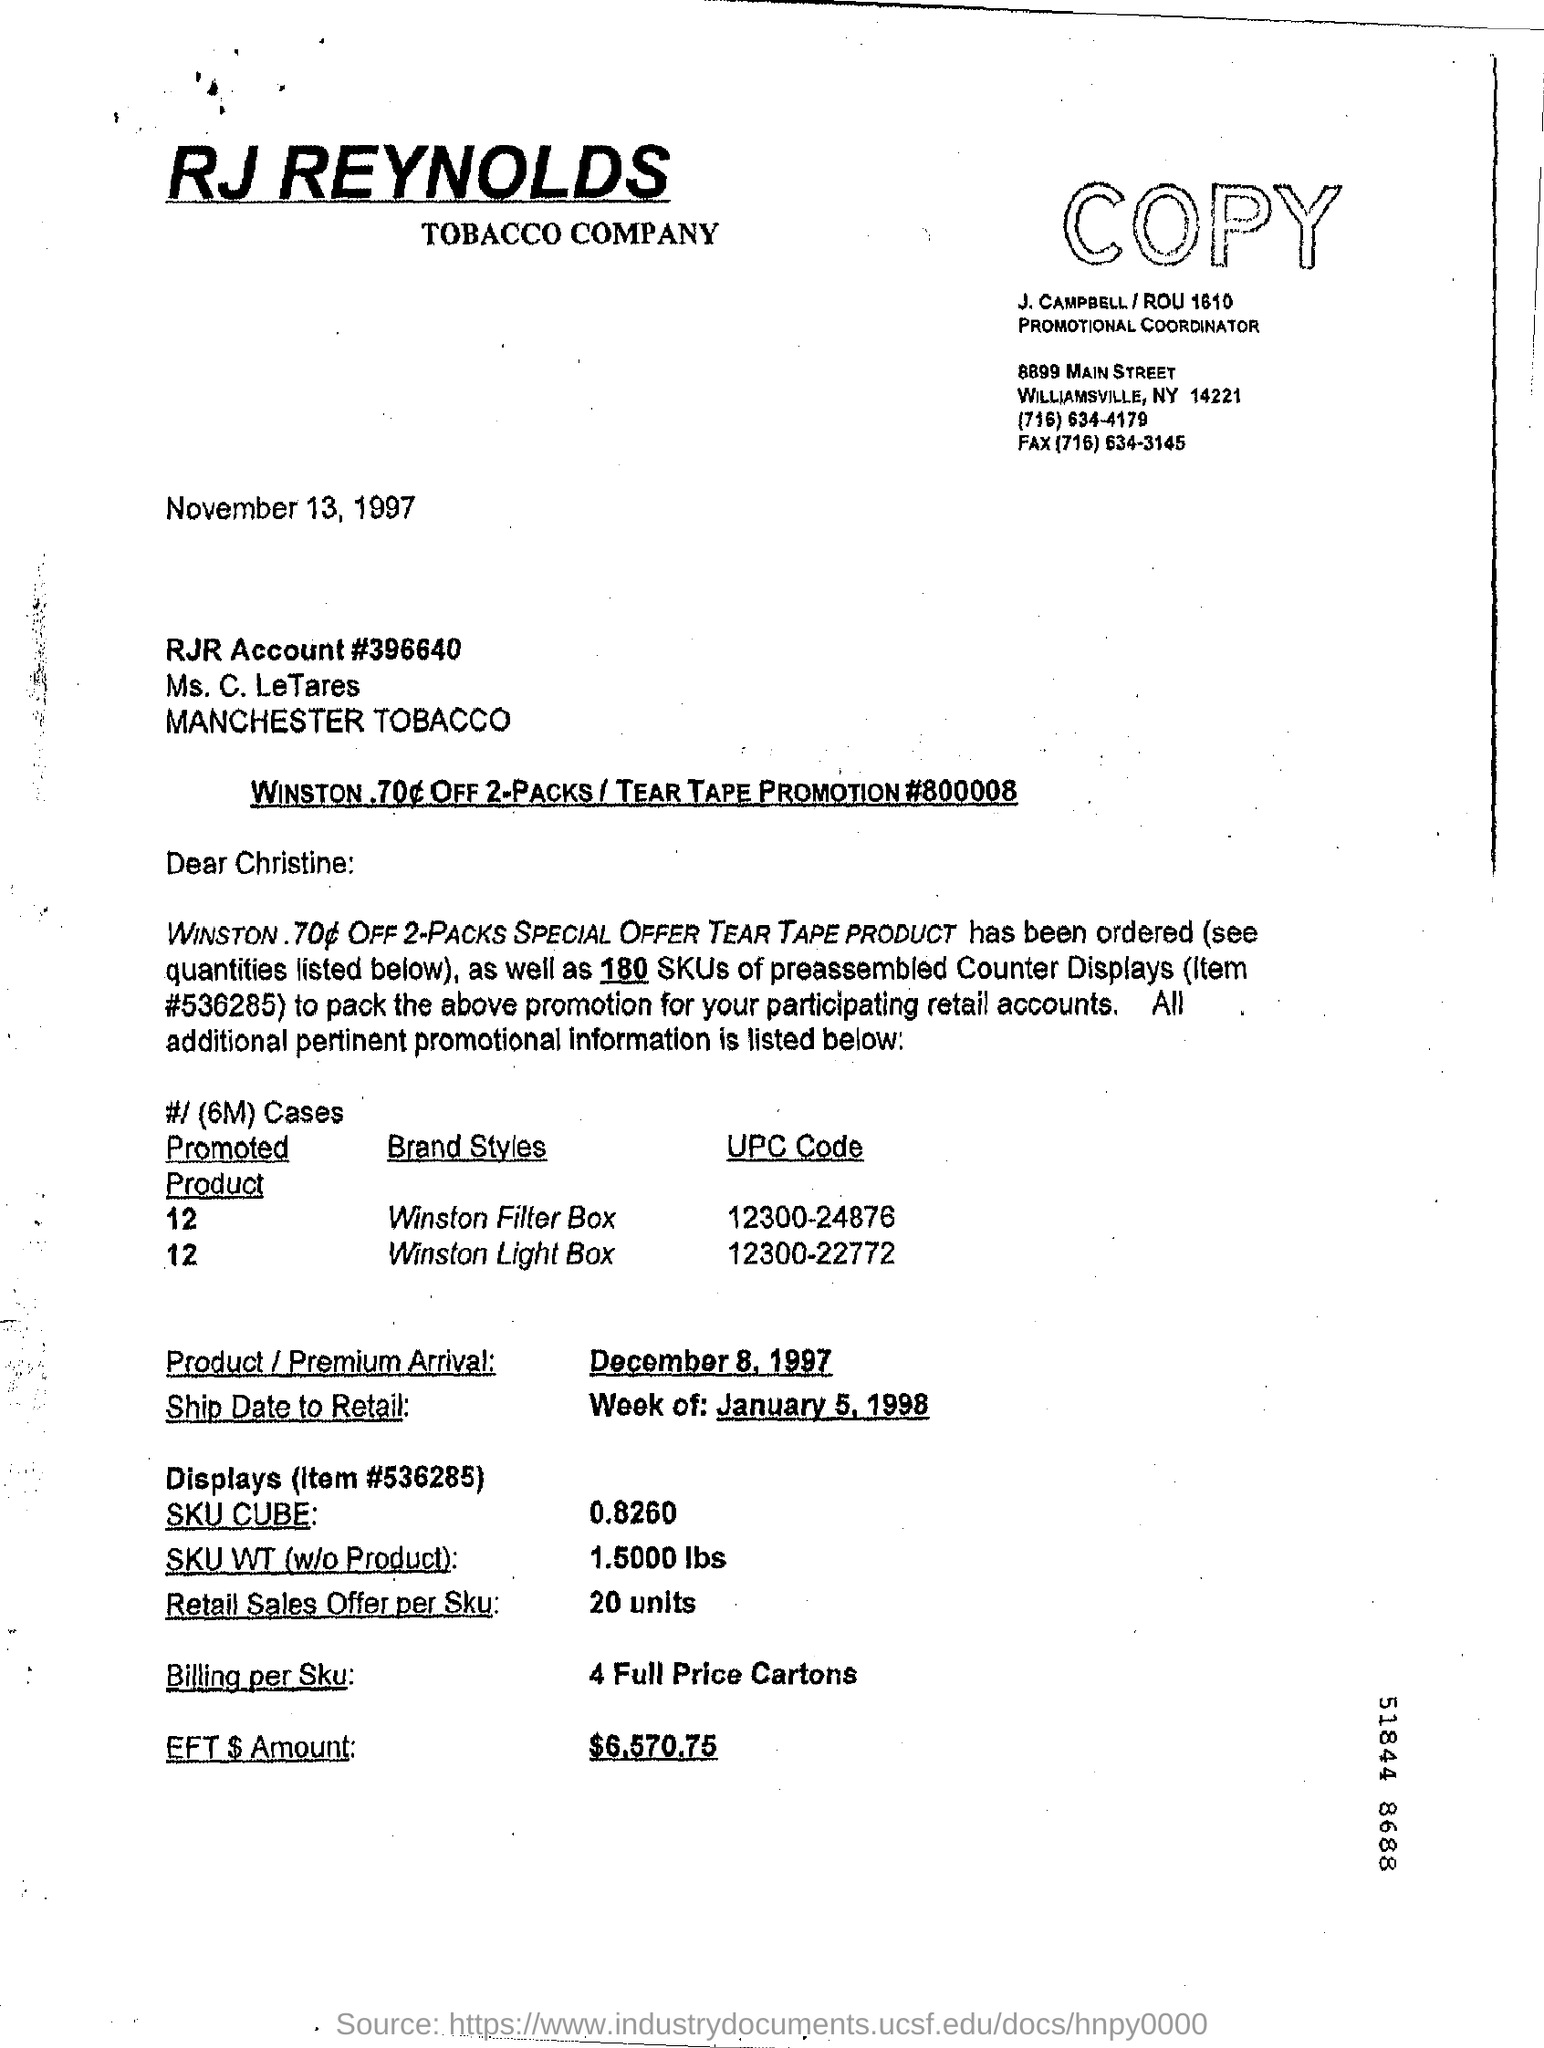What are the implications of having this document publicly accessible? Having this document publicly accessible provides insights into the historical marketing practices of the tobacco industry, including their promotional strategies and communication with retailers. It can serve as a point of study for understanding how tobacco products were historically distributed and marketed, as well as the meticulous planning that went into sales promotions. Additionally, it can inform public health discussions and policy-making related to tobacco control, by offering a snapshot of past industry behaviors. 